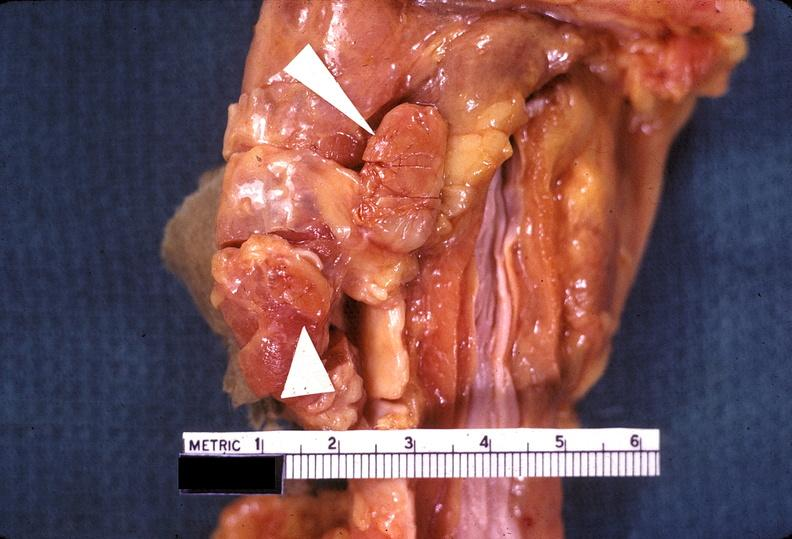what does this image show?
Answer the question using a single word or phrase. Parathyroid hyperplasia 